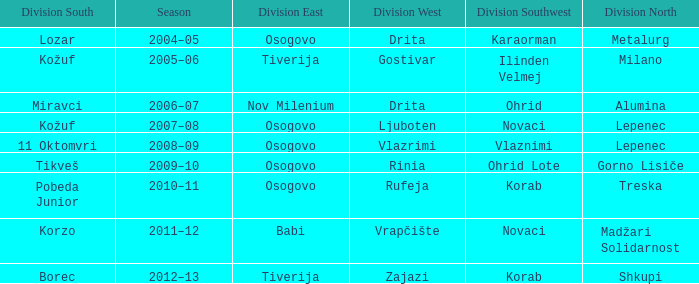Who won Division West when Division North was won by Alumina? Drita. 